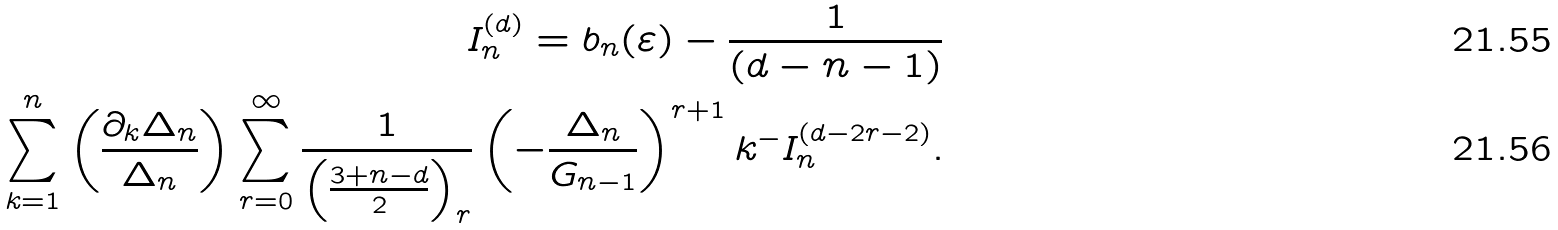Convert formula to latex. <formula><loc_0><loc_0><loc_500><loc_500>I _ { n } ^ { ( d ) } = b _ { n } ( \varepsilon ) - \frac { 1 } { ( d - n - 1 ) } \\ \sum _ { k = 1 } ^ { n } \left ( \frac { \partial _ { k } \Delta _ { n } } { \Delta _ { n } } \right ) \sum _ { r = 0 } ^ { \infty } \frac { 1 } { \left ( \frac { 3 + n - d } { 2 } \right ) _ { r } } \left ( - \frac { \Delta _ { n } } { G _ { n - 1 } } \right ) ^ { r + 1 } { k ^ { - } } I _ { n } ^ { ( d - 2 r - 2 ) } .</formula> 